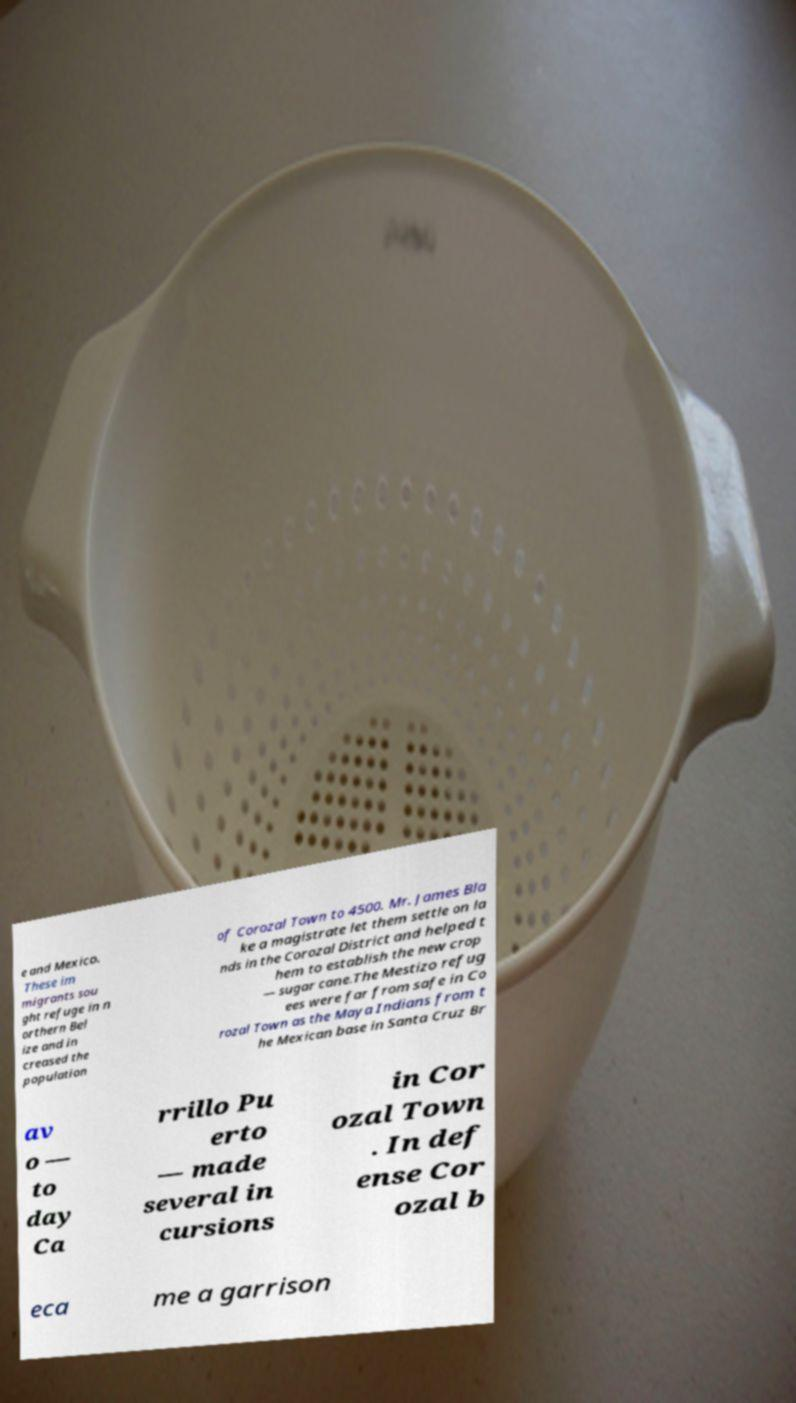Please identify and transcribe the text found in this image. e and Mexico. These im migrants sou ght refuge in n orthern Bel ize and in creased the population of Corozal Town to 4500. Mr. James Bla ke a magistrate let them settle on la nds in the Corozal District and helped t hem to establish the new crop — sugar cane.The Mestizo refug ees were far from safe in Co rozal Town as the Maya Indians from t he Mexican base in Santa Cruz Br av o — to day Ca rrillo Pu erto — made several in cursions in Cor ozal Town . In def ense Cor ozal b eca me a garrison 